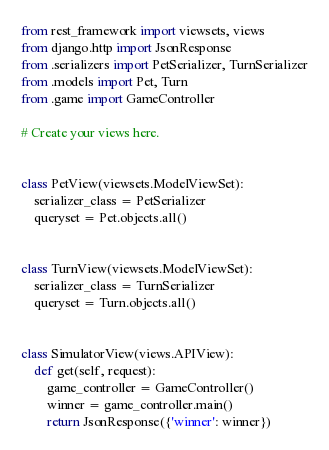<code> <loc_0><loc_0><loc_500><loc_500><_Python_>from rest_framework import viewsets, views
from django.http import JsonResponse
from .serializers import PetSerializer, TurnSerializer
from .models import Pet, Turn
from .game import GameController

# Create your views here.


class PetView(viewsets.ModelViewSet):
    serializer_class = PetSerializer
    queryset = Pet.objects.all()


class TurnView(viewsets.ModelViewSet):
    serializer_class = TurnSerializer
    queryset = Turn.objects.all()


class SimulatorView(views.APIView):
    def get(self, request):
        game_controller = GameController()
        winner = game_controller.main()
        return JsonResponse({'winner': winner})
</code> 